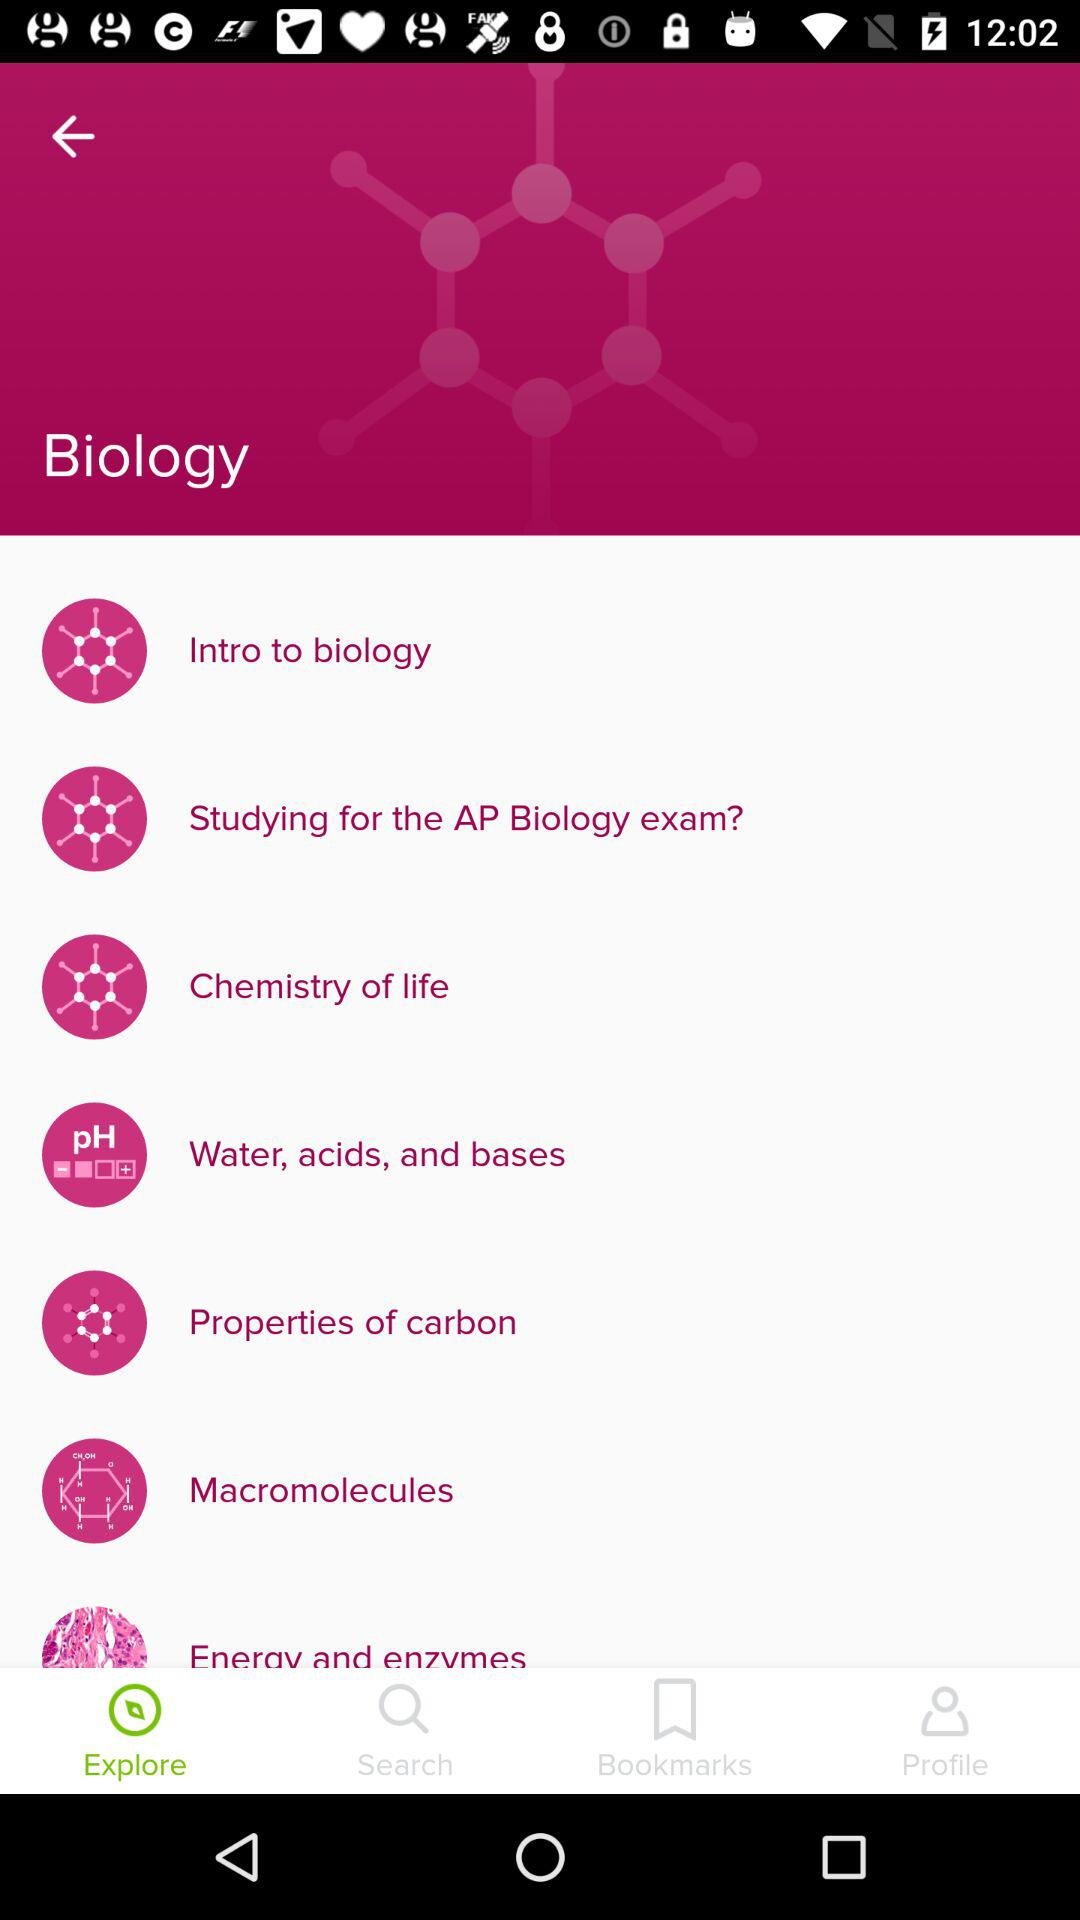How many bookmarks are there?
When the provided information is insufficient, respond with <no answer>. <no answer> 